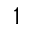<formula> <loc_0><loc_0><loc_500><loc_500>1</formula> 